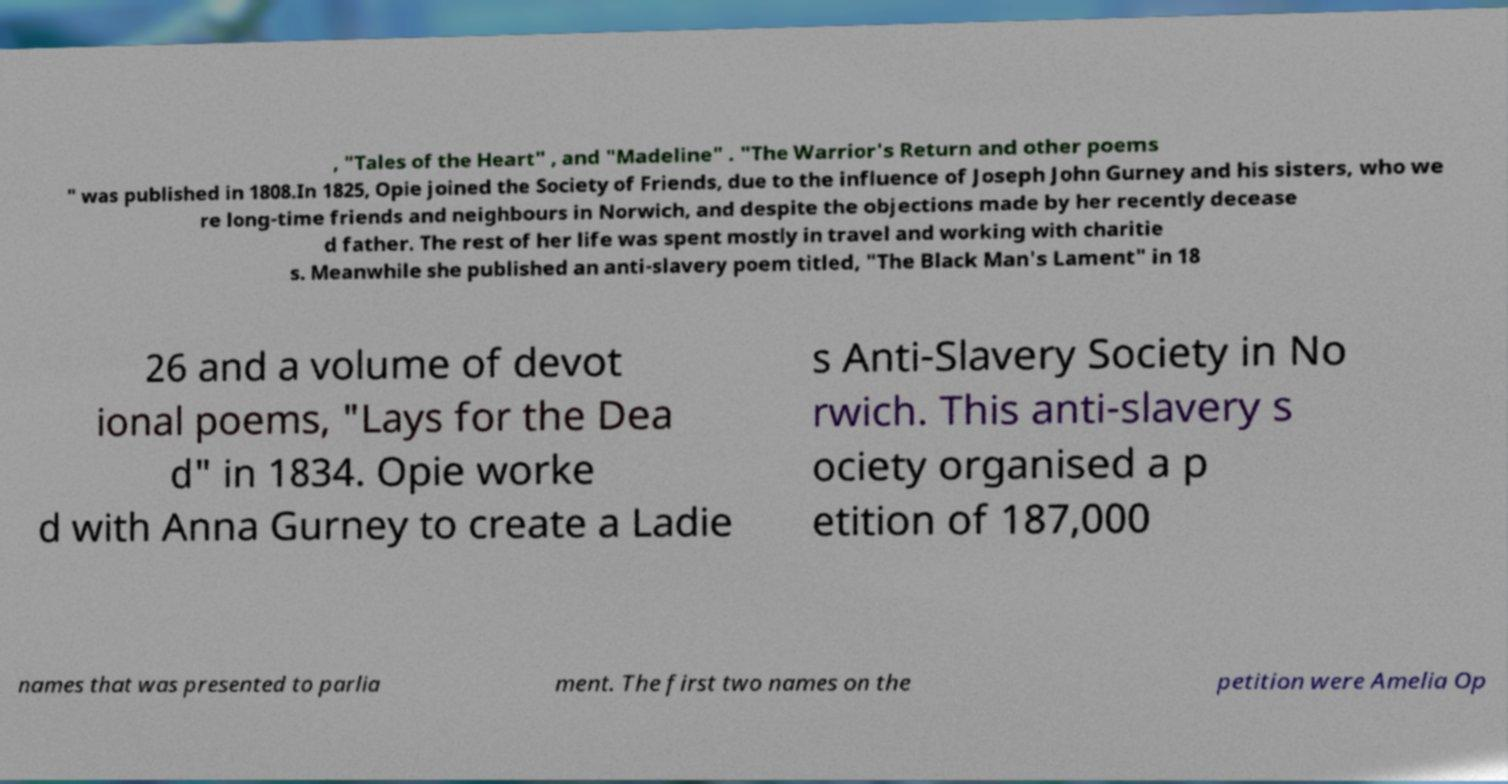There's text embedded in this image that I need extracted. Can you transcribe it verbatim? , "Tales of the Heart" , and "Madeline" . "The Warrior's Return and other poems " was published in 1808.In 1825, Opie joined the Society of Friends, due to the influence of Joseph John Gurney and his sisters, who we re long-time friends and neighbours in Norwich, and despite the objections made by her recently decease d father. The rest of her life was spent mostly in travel and working with charitie s. Meanwhile she published an anti-slavery poem titled, "The Black Man's Lament" in 18 26 and a volume of devot ional poems, "Lays for the Dea d" in 1834. Opie worke d with Anna Gurney to create a Ladie s Anti-Slavery Society in No rwich. This anti-slavery s ociety organised a p etition of 187,000 names that was presented to parlia ment. The first two names on the petition were Amelia Op 